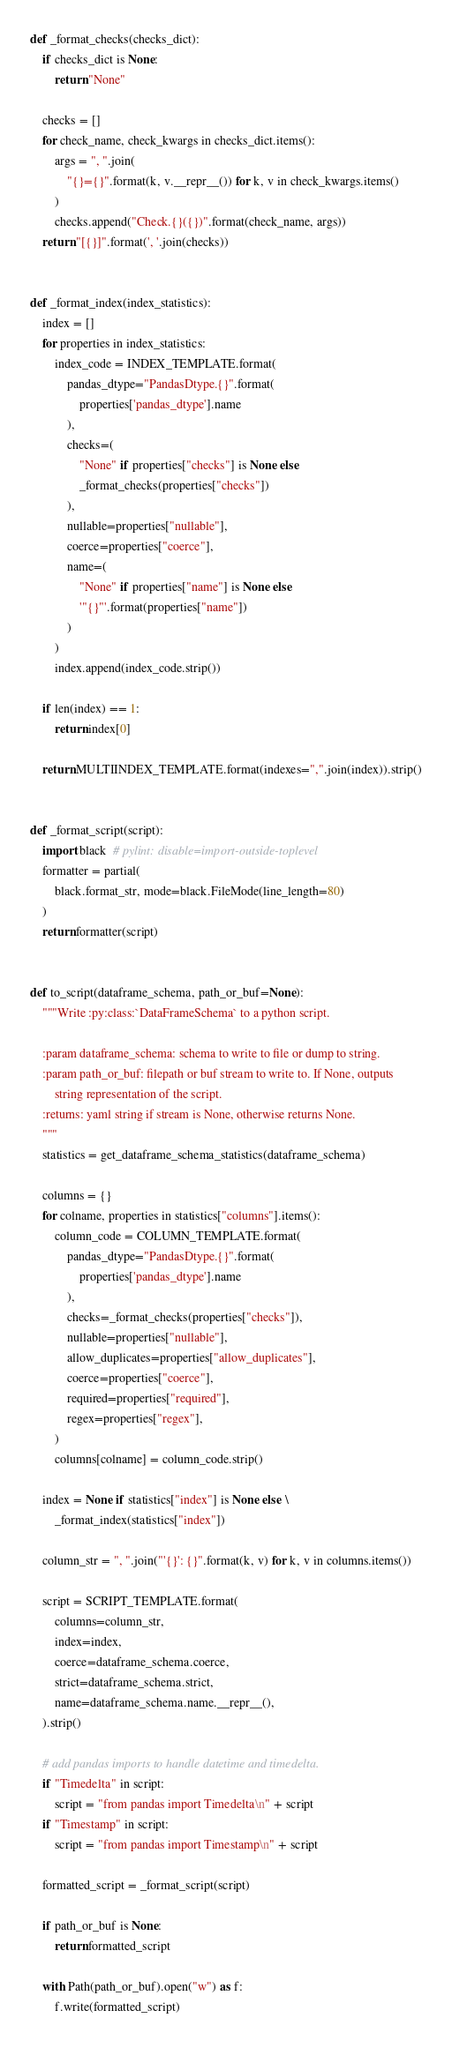Convert code to text. <code><loc_0><loc_0><loc_500><loc_500><_Python_>
def _format_checks(checks_dict):
    if checks_dict is None:
        return "None"

    checks = []
    for check_name, check_kwargs in checks_dict.items():
        args = ", ".join(
            "{}={}".format(k, v.__repr__()) for k, v in check_kwargs.items()
        )
        checks.append("Check.{}({})".format(check_name, args))
    return "[{}]".format(', '.join(checks))


def _format_index(index_statistics):
    index = []
    for properties in index_statistics:
        index_code = INDEX_TEMPLATE.format(
            pandas_dtype="PandasDtype.{}".format(
                properties['pandas_dtype'].name
            ),
            checks=(
                "None" if properties["checks"] is None else
                _format_checks(properties["checks"])
            ),
            nullable=properties["nullable"],
            coerce=properties["coerce"],
            name=(
                "None" if properties["name"] is None else
                '"{}"'.format(properties["name"])
            )
        )
        index.append(index_code.strip())

    if len(index) == 1:
        return index[0]

    return MULTIINDEX_TEMPLATE.format(indexes=",".join(index)).strip()


def _format_script(script):
    import black  # pylint: disable=import-outside-toplevel
    formatter = partial(
        black.format_str, mode=black.FileMode(line_length=80)
    )
    return formatter(script)


def to_script(dataframe_schema, path_or_buf=None):
    """Write :py:class:`DataFrameSchema` to a python script.

    :param dataframe_schema: schema to write to file or dump to string.
    :param path_or_buf: filepath or buf stream to write to. If None, outputs
        string representation of the script.
    :returns: yaml string if stream is None, otherwise returns None.
    """
    statistics = get_dataframe_schema_statistics(dataframe_schema)

    columns = {}
    for colname, properties in statistics["columns"].items():
        column_code = COLUMN_TEMPLATE.format(
            pandas_dtype="PandasDtype.{}".format(
                properties['pandas_dtype'].name
            ),
            checks=_format_checks(properties["checks"]),
            nullable=properties["nullable"],
            allow_duplicates=properties["allow_duplicates"],
            coerce=properties["coerce"],
            required=properties["required"],
            regex=properties["regex"],
        )
        columns[colname] = column_code.strip()

    index = None if statistics["index"] is None else \
        _format_index(statistics["index"])

    column_str = ", ".join("'{}': {}".format(k, v) for k, v in columns.items())

    script = SCRIPT_TEMPLATE.format(
        columns=column_str,
        index=index,
        coerce=dataframe_schema.coerce,
        strict=dataframe_schema.strict,
        name=dataframe_schema.name.__repr__(),
    ).strip()

    # add pandas imports to handle datetime and timedelta.
    if "Timedelta" in script:
        script = "from pandas import Timedelta\n" + script
    if "Timestamp" in script:
        script = "from pandas import Timestamp\n" + script

    formatted_script = _format_script(script)

    if path_or_buf is None:
        return formatted_script

    with Path(path_or_buf).open("w") as f:
        f.write(formatted_script)
</code> 